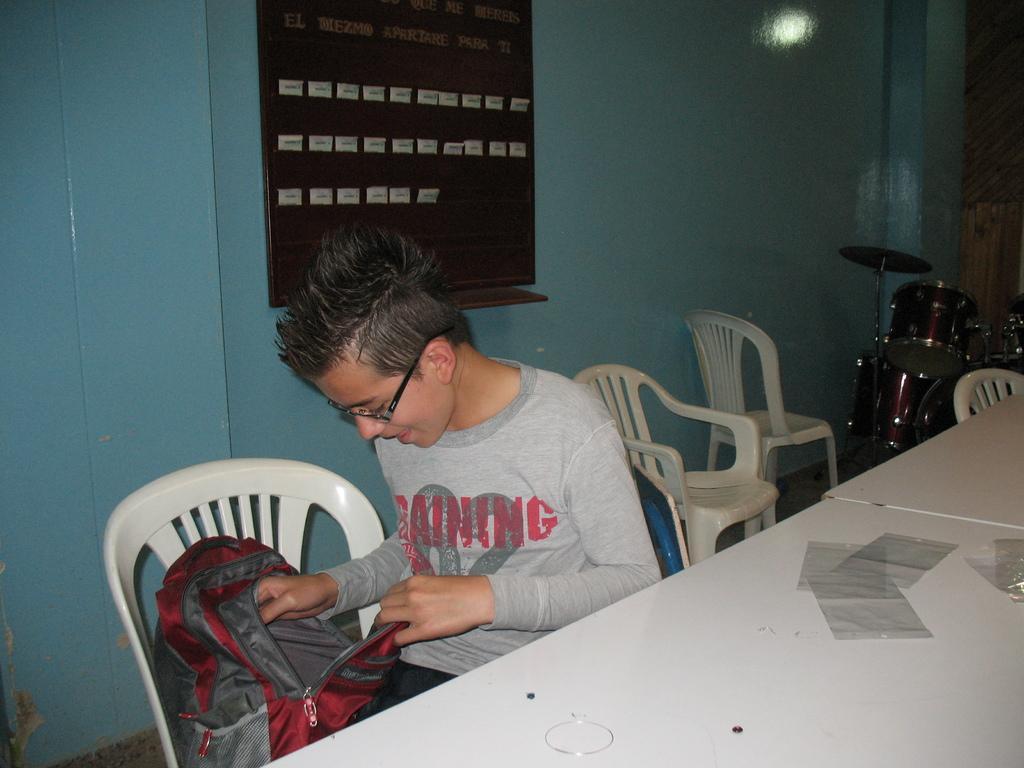Could you give a brief overview of what you see in this image? The kid is sitting in a chair and looking into a red back and there is a table in front of him and there are drums in the background. 